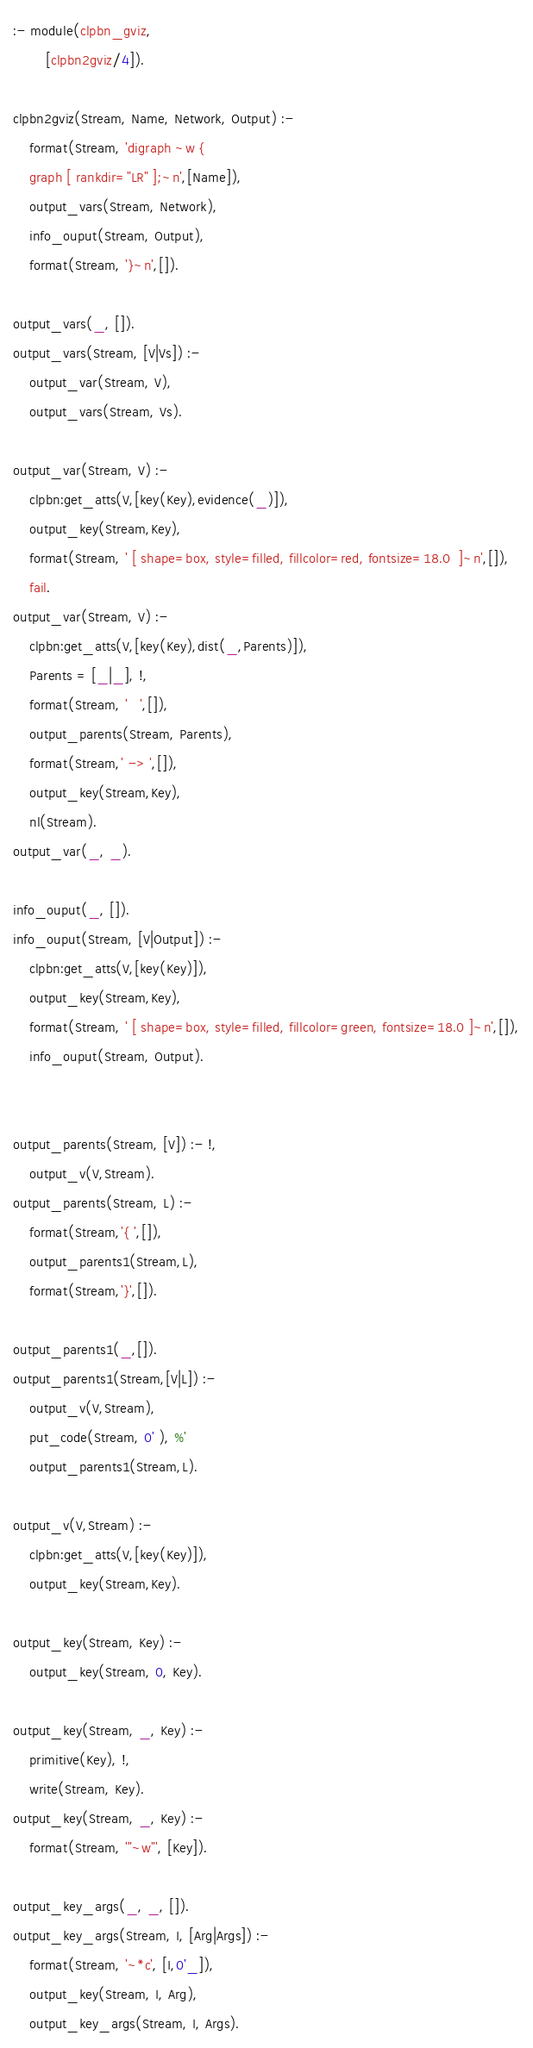<code> <loc_0><loc_0><loc_500><loc_500><_Prolog_>
:- module(clpbn_gviz,
		[clpbn2gviz/4]).

clpbn2gviz(Stream, Name, Network, Output) :-
	format(Stream, 'digraph ~w {
	graph [ rankdir="LR" ];~n',[Name]),
	output_vars(Stream, Network),
	info_ouput(Stream, Output),
	format(Stream, '}~n',[]).

output_vars(_, []).
output_vars(Stream, [V|Vs]) :-
	output_var(Stream, V),
	output_vars(Stream, Vs).

output_var(Stream, V) :-
	clpbn:get_atts(V,[key(Key),evidence(_)]),
	output_key(Stream,Key),
	format(Stream, ' [ shape=box, style=filled, fillcolor=red, fontsize=18.0  ]~n',[]),
	fail.
output_var(Stream, V) :-
	clpbn:get_atts(V,[key(Key),dist(_,Parents)]),
	Parents = [_|_], !,
	format(Stream, '	',[]),
	output_parents(Stream, Parents),
	format(Stream,' -> ',[]),
	output_key(Stream,Key),
	nl(Stream).
output_var(_, _).

info_ouput(_, []).
info_ouput(Stream, [V|Output]) :-
	clpbn:get_atts(V,[key(Key)]),
	output_key(Stream,Key),
	format(Stream, ' [ shape=box, style=filled, fillcolor=green, fontsize=18.0 ]~n',[]),
	info_ouput(Stream, Output).


output_parents(Stream, [V]) :- !,
	output_v(V,Stream).
output_parents(Stream, L) :-
	format(Stream,'{ ',[]),
	output_parents1(Stream,L),
	format(Stream,'}',[]).

output_parents1(_,[]).
output_parents1(Stream,[V|L]) :-
	output_v(V,Stream),
	put_code(Stream, 0' ), %'
	output_parents1(Stream,L).

output_v(V,Stream) :-
	clpbn:get_atts(V,[key(Key)]),
	output_key(Stream,Key).

output_key(Stream, Key) :-
	output_key(Stream, 0, Key).

output_key(Stream, _, Key) :-
	primitive(Key), !,
	write(Stream, Key).
output_key(Stream, _, Key) :-
	format(Stream, '"~w"', [Key]).

output_key_args(_, _, []).
output_key_args(Stream, I, [Arg|Args]) :-
	format(Stream, '~*c', [I,0'_]),
	output_key(Stream, I, Arg),
	output_key_args(Stream, I, Args).

</code> 